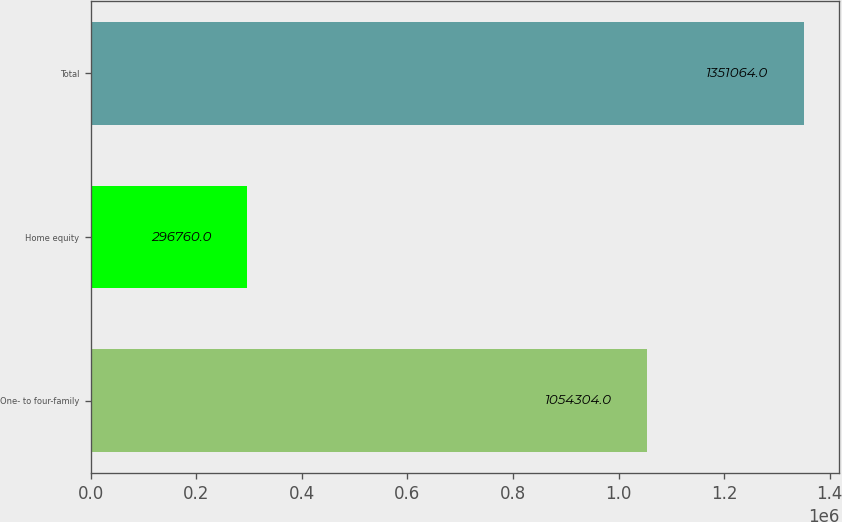<chart> <loc_0><loc_0><loc_500><loc_500><bar_chart><fcel>One- to four-family<fcel>Home equity<fcel>Total<nl><fcel>1.0543e+06<fcel>296760<fcel>1.35106e+06<nl></chart> 